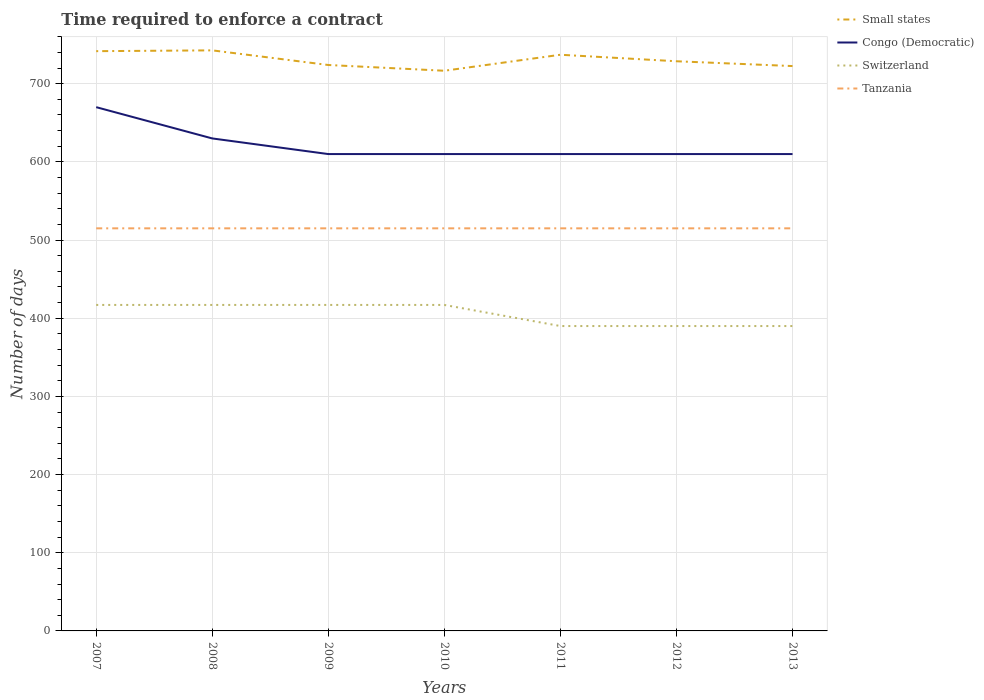Does the line corresponding to Tanzania intersect with the line corresponding to Switzerland?
Your answer should be very brief. No. Is the number of lines equal to the number of legend labels?
Keep it short and to the point. Yes. Across all years, what is the maximum number of days required to enforce a contract in Tanzania?
Ensure brevity in your answer.  515. In which year was the number of days required to enforce a contract in Congo (Democratic) maximum?
Offer a very short reply. 2009. What is the total number of days required to enforce a contract in Congo (Democratic) in the graph?
Your response must be concise. 60. What is the difference between the highest and the second highest number of days required to enforce a contract in Small states?
Give a very brief answer. 26.08. What is the difference between the highest and the lowest number of days required to enforce a contract in Congo (Democratic)?
Your response must be concise. 2. How many years are there in the graph?
Your answer should be compact. 7. What is the difference between two consecutive major ticks on the Y-axis?
Offer a very short reply. 100. How many legend labels are there?
Ensure brevity in your answer.  4. What is the title of the graph?
Offer a terse response. Time required to enforce a contract. Does "Finland" appear as one of the legend labels in the graph?
Provide a short and direct response. No. What is the label or title of the Y-axis?
Keep it short and to the point. Number of days. What is the Number of days of Small states in 2007?
Keep it short and to the point. 741.64. What is the Number of days in Congo (Democratic) in 2007?
Offer a very short reply. 670. What is the Number of days in Switzerland in 2007?
Keep it short and to the point. 417. What is the Number of days in Tanzania in 2007?
Ensure brevity in your answer.  515. What is the Number of days of Small states in 2008?
Your answer should be compact. 742.67. What is the Number of days in Congo (Democratic) in 2008?
Ensure brevity in your answer.  630. What is the Number of days of Switzerland in 2008?
Make the answer very short. 417. What is the Number of days of Tanzania in 2008?
Offer a very short reply. 515. What is the Number of days in Small states in 2009?
Provide a succinct answer. 723.95. What is the Number of days of Congo (Democratic) in 2009?
Provide a short and direct response. 610. What is the Number of days of Switzerland in 2009?
Ensure brevity in your answer.  417. What is the Number of days in Tanzania in 2009?
Your response must be concise. 515. What is the Number of days of Small states in 2010?
Offer a very short reply. 716.59. What is the Number of days of Congo (Democratic) in 2010?
Make the answer very short. 610. What is the Number of days of Switzerland in 2010?
Provide a short and direct response. 417. What is the Number of days in Tanzania in 2010?
Make the answer very short. 515. What is the Number of days in Small states in 2011?
Your answer should be very brief. 737.05. What is the Number of days in Congo (Democratic) in 2011?
Offer a very short reply. 610. What is the Number of days in Switzerland in 2011?
Provide a short and direct response. 390. What is the Number of days of Tanzania in 2011?
Keep it short and to the point. 515. What is the Number of days in Small states in 2012?
Give a very brief answer. 728.73. What is the Number of days of Congo (Democratic) in 2012?
Give a very brief answer. 610. What is the Number of days in Switzerland in 2012?
Your response must be concise. 390. What is the Number of days of Tanzania in 2012?
Your response must be concise. 515. What is the Number of days in Small states in 2013?
Make the answer very short. 722.58. What is the Number of days of Congo (Democratic) in 2013?
Provide a short and direct response. 610. What is the Number of days in Switzerland in 2013?
Offer a very short reply. 390. What is the Number of days of Tanzania in 2013?
Ensure brevity in your answer.  515. Across all years, what is the maximum Number of days in Small states?
Give a very brief answer. 742.67. Across all years, what is the maximum Number of days of Congo (Democratic)?
Offer a terse response. 670. Across all years, what is the maximum Number of days of Switzerland?
Give a very brief answer. 417. Across all years, what is the maximum Number of days in Tanzania?
Make the answer very short. 515. Across all years, what is the minimum Number of days in Small states?
Offer a terse response. 716.59. Across all years, what is the minimum Number of days of Congo (Democratic)?
Provide a succinct answer. 610. Across all years, what is the minimum Number of days of Switzerland?
Your answer should be very brief. 390. Across all years, what is the minimum Number of days of Tanzania?
Offer a terse response. 515. What is the total Number of days of Small states in the graph?
Provide a succinct answer. 5113.2. What is the total Number of days in Congo (Democratic) in the graph?
Give a very brief answer. 4350. What is the total Number of days of Switzerland in the graph?
Your response must be concise. 2838. What is the total Number of days in Tanzania in the graph?
Give a very brief answer. 3605. What is the difference between the Number of days in Small states in 2007 and that in 2008?
Provide a succinct answer. -1.03. What is the difference between the Number of days of Switzerland in 2007 and that in 2008?
Your response must be concise. 0. What is the difference between the Number of days in Small states in 2007 and that in 2009?
Your answer should be compact. 17.69. What is the difference between the Number of days of Congo (Democratic) in 2007 and that in 2009?
Your answer should be compact. 60. What is the difference between the Number of days of Switzerland in 2007 and that in 2009?
Your answer should be very brief. 0. What is the difference between the Number of days of Small states in 2007 and that in 2010?
Keep it short and to the point. 25.05. What is the difference between the Number of days of Congo (Democratic) in 2007 and that in 2010?
Offer a very short reply. 60. What is the difference between the Number of days in Small states in 2007 and that in 2011?
Provide a succinct answer. 4.59. What is the difference between the Number of days of Congo (Democratic) in 2007 and that in 2011?
Give a very brief answer. 60. What is the difference between the Number of days of Tanzania in 2007 and that in 2011?
Your answer should be very brief. 0. What is the difference between the Number of days of Small states in 2007 and that in 2012?
Your answer should be very brief. 12.92. What is the difference between the Number of days of Switzerland in 2007 and that in 2012?
Your answer should be very brief. 27. What is the difference between the Number of days in Small states in 2007 and that in 2013?
Keep it short and to the point. 19.07. What is the difference between the Number of days of Congo (Democratic) in 2007 and that in 2013?
Your answer should be compact. 60. What is the difference between the Number of days in Small states in 2008 and that in 2009?
Give a very brief answer. 18.72. What is the difference between the Number of days of Tanzania in 2008 and that in 2009?
Offer a very short reply. 0. What is the difference between the Number of days of Small states in 2008 and that in 2010?
Your answer should be compact. 26.08. What is the difference between the Number of days of Tanzania in 2008 and that in 2010?
Your response must be concise. 0. What is the difference between the Number of days in Small states in 2008 and that in 2011?
Provide a succinct answer. 5.62. What is the difference between the Number of days in Tanzania in 2008 and that in 2011?
Your answer should be very brief. 0. What is the difference between the Number of days of Small states in 2008 and that in 2012?
Provide a succinct answer. 13.94. What is the difference between the Number of days in Congo (Democratic) in 2008 and that in 2012?
Offer a terse response. 20. What is the difference between the Number of days of Small states in 2008 and that in 2013?
Ensure brevity in your answer.  20.09. What is the difference between the Number of days of Congo (Democratic) in 2008 and that in 2013?
Offer a terse response. 20. What is the difference between the Number of days in Switzerland in 2008 and that in 2013?
Ensure brevity in your answer.  27. What is the difference between the Number of days in Tanzania in 2008 and that in 2013?
Offer a very short reply. 0. What is the difference between the Number of days in Small states in 2009 and that in 2010?
Keep it short and to the point. 7.36. What is the difference between the Number of days in Congo (Democratic) in 2009 and that in 2010?
Offer a very short reply. 0. What is the difference between the Number of days in Switzerland in 2009 and that in 2010?
Give a very brief answer. 0. What is the difference between the Number of days in Tanzania in 2009 and that in 2010?
Provide a short and direct response. 0. What is the difference between the Number of days of Small states in 2009 and that in 2011?
Offer a terse response. -13.1. What is the difference between the Number of days of Small states in 2009 and that in 2012?
Provide a succinct answer. -4.78. What is the difference between the Number of days in Congo (Democratic) in 2009 and that in 2012?
Ensure brevity in your answer.  0. What is the difference between the Number of days in Switzerland in 2009 and that in 2012?
Make the answer very short. 27. What is the difference between the Number of days in Small states in 2009 and that in 2013?
Give a very brief answer. 1.37. What is the difference between the Number of days of Congo (Democratic) in 2009 and that in 2013?
Give a very brief answer. 0. What is the difference between the Number of days of Small states in 2010 and that in 2011?
Provide a short and direct response. -20.46. What is the difference between the Number of days of Switzerland in 2010 and that in 2011?
Offer a very short reply. 27. What is the difference between the Number of days of Tanzania in 2010 and that in 2011?
Your response must be concise. 0. What is the difference between the Number of days in Small states in 2010 and that in 2012?
Provide a succinct answer. -12.14. What is the difference between the Number of days of Congo (Democratic) in 2010 and that in 2012?
Your answer should be very brief. 0. What is the difference between the Number of days in Switzerland in 2010 and that in 2012?
Offer a terse response. 27. What is the difference between the Number of days of Tanzania in 2010 and that in 2012?
Offer a terse response. 0. What is the difference between the Number of days in Small states in 2010 and that in 2013?
Ensure brevity in your answer.  -5.99. What is the difference between the Number of days of Congo (Democratic) in 2010 and that in 2013?
Your answer should be very brief. 0. What is the difference between the Number of days of Switzerland in 2010 and that in 2013?
Make the answer very short. 27. What is the difference between the Number of days of Tanzania in 2010 and that in 2013?
Make the answer very short. 0. What is the difference between the Number of days of Small states in 2011 and that in 2012?
Provide a short and direct response. 8.32. What is the difference between the Number of days in Tanzania in 2011 and that in 2012?
Your answer should be compact. 0. What is the difference between the Number of days of Small states in 2011 and that in 2013?
Make the answer very short. 14.47. What is the difference between the Number of days in Tanzania in 2011 and that in 2013?
Give a very brief answer. 0. What is the difference between the Number of days in Small states in 2012 and that in 2013?
Provide a succinct answer. 6.15. What is the difference between the Number of days in Congo (Democratic) in 2012 and that in 2013?
Your response must be concise. 0. What is the difference between the Number of days of Switzerland in 2012 and that in 2013?
Your answer should be compact. 0. What is the difference between the Number of days in Tanzania in 2012 and that in 2013?
Your response must be concise. 0. What is the difference between the Number of days of Small states in 2007 and the Number of days of Congo (Democratic) in 2008?
Keep it short and to the point. 111.64. What is the difference between the Number of days in Small states in 2007 and the Number of days in Switzerland in 2008?
Provide a succinct answer. 324.64. What is the difference between the Number of days of Small states in 2007 and the Number of days of Tanzania in 2008?
Ensure brevity in your answer.  226.64. What is the difference between the Number of days in Congo (Democratic) in 2007 and the Number of days in Switzerland in 2008?
Offer a terse response. 253. What is the difference between the Number of days in Congo (Democratic) in 2007 and the Number of days in Tanzania in 2008?
Your response must be concise. 155. What is the difference between the Number of days in Switzerland in 2007 and the Number of days in Tanzania in 2008?
Offer a terse response. -98. What is the difference between the Number of days of Small states in 2007 and the Number of days of Congo (Democratic) in 2009?
Your answer should be very brief. 131.64. What is the difference between the Number of days in Small states in 2007 and the Number of days in Switzerland in 2009?
Provide a short and direct response. 324.64. What is the difference between the Number of days of Small states in 2007 and the Number of days of Tanzania in 2009?
Ensure brevity in your answer.  226.64. What is the difference between the Number of days of Congo (Democratic) in 2007 and the Number of days of Switzerland in 2009?
Give a very brief answer. 253. What is the difference between the Number of days in Congo (Democratic) in 2007 and the Number of days in Tanzania in 2009?
Offer a very short reply. 155. What is the difference between the Number of days of Switzerland in 2007 and the Number of days of Tanzania in 2009?
Your answer should be compact. -98. What is the difference between the Number of days in Small states in 2007 and the Number of days in Congo (Democratic) in 2010?
Offer a terse response. 131.64. What is the difference between the Number of days of Small states in 2007 and the Number of days of Switzerland in 2010?
Make the answer very short. 324.64. What is the difference between the Number of days of Small states in 2007 and the Number of days of Tanzania in 2010?
Provide a short and direct response. 226.64. What is the difference between the Number of days of Congo (Democratic) in 2007 and the Number of days of Switzerland in 2010?
Your answer should be very brief. 253. What is the difference between the Number of days in Congo (Democratic) in 2007 and the Number of days in Tanzania in 2010?
Provide a short and direct response. 155. What is the difference between the Number of days in Switzerland in 2007 and the Number of days in Tanzania in 2010?
Offer a very short reply. -98. What is the difference between the Number of days of Small states in 2007 and the Number of days of Congo (Democratic) in 2011?
Give a very brief answer. 131.64. What is the difference between the Number of days in Small states in 2007 and the Number of days in Switzerland in 2011?
Offer a very short reply. 351.64. What is the difference between the Number of days in Small states in 2007 and the Number of days in Tanzania in 2011?
Make the answer very short. 226.64. What is the difference between the Number of days of Congo (Democratic) in 2007 and the Number of days of Switzerland in 2011?
Provide a short and direct response. 280. What is the difference between the Number of days of Congo (Democratic) in 2007 and the Number of days of Tanzania in 2011?
Make the answer very short. 155. What is the difference between the Number of days of Switzerland in 2007 and the Number of days of Tanzania in 2011?
Make the answer very short. -98. What is the difference between the Number of days in Small states in 2007 and the Number of days in Congo (Democratic) in 2012?
Give a very brief answer. 131.64. What is the difference between the Number of days in Small states in 2007 and the Number of days in Switzerland in 2012?
Provide a succinct answer. 351.64. What is the difference between the Number of days in Small states in 2007 and the Number of days in Tanzania in 2012?
Provide a succinct answer. 226.64. What is the difference between the Number of days of Congo (Democratic) in 2007 and the Number of days of Switzerland in 2012?
Make the answer very short. 280. What is the difference between the Number of days in Congo (Democratic) in 2007 and the Number of days in Tanzania in 2012?
Make the answer very short. 155. What is the difference between the Number of days in Switzerland in 2007 and the Number of days in Tanzania in 2012?
Provide a succinct answer. -98. What is the difference between the Number of days of Small states in 2007 and the Number of days of Congo (Democratic) in 2013?
Your answer should be very brief. 131.64. What is the difference between the Number of days in Small states in 2007 and the Number of days in Switzerland in 2013?
Your answer should be compact. 351.64. What is the difference between the Number of days of Small states in 2007 and the Number of days of Tanzania in 2013?
Give a very brief answer. 226.64. What is the difference between the Number of days in Congo (Democratic) in 2007 and the Number of days in Switzerland in 2013?
Your answer should be very brief. 280. What is the difference between the Number of days in Congo (Democratic) in 2007 and the Number of days in Tanzania in 2013?
Offer a terse response. 155. What is the difference between the Number of days of Switzerland in 2007 and the Number of days of Tanzania in 2013?
Make the answer very short. -98. What is the difference between the Number of days of Small states in 2008 and the Number of days of Congo (Democratic) in 2009?
Make the answer very short. 132.67. What is the difference between the Number of days in Small states in 2008 and the Number of days in Switzerland in 2009?
Provide a short and direct response. 325.67. What is the difference between the Number of days in Small states in 2008 and the Number of days in Tanzania in 2009?
Offer a very short reply. 227.67. What is the difference between the Number of days of Congo (Democratic) in 2008 and the Number of days of Switzerland in 2009?
Provide a short and direct response. 213. What is the difference between the Number of days in Congo (Democratic) in 2008 and the Number of days in Tanzania in 2009?
Make the answer very short. 115. What is the difference between the Number of days of Switzerland in 2008 and the Number of days of Tanzania in 2009?
Offer a very short reply. -98. What is the difference between the Number of days in Small states in 2008 and the Number of days in Congo (Democratic) in 2010?
Offer a very short reply. 132.67. What is the difference between the Number of days in Small states in 2008 and the Number of days in Switzerland in 2010?
Your response must be concise. 325.67. What is the difference between the Number of days in Small states in 2008 and the Number of days in Tanzania in 2010?
Provide a succinct answer. 227.67. What is the difference between the Number of days in Congo (Democratic) in 2008 and the Number of days in Switzerland in 2010?
Offer a terse response. 213. What is the difference between the Number of days of Congo (Democratic) in 2008 and the Number of days of Tanzania in 2010?
Provide a short and direct response. 115. What is the difference between the Number of days of Switzerland in 2008 and the Number of days of Tanzania in 2010?
Make the answer very short. -98. What is the difference between the Number of days of Small states in 2008 and the Number of days of Congo (Democratic) in 2011?
Make the answer very short. 132.67. What is the difference between the Number of days of Small states in 2008 and the Number of days of Switzerland in 2011?
Provide a succinct answer. 352.67. What is the difference between the Number of days in Small states in 2008 and the Number of days in Tanzania in 2011?
Your answer should be compact. 227.67. What is the difference between the Number of days in Congo (Democratic) in 2008 and the Number of days in Switzerland in 2011?
Offer a terse response. 240. What is the difference between the Number of days in Congo (Democratic) in 2008 and the Number of days in Tanzania in 2011?
Your response must be concise. 115. What is the difference between the Number of days in Switzerland in 2008 and the Number of days in Tanzania in 2011?
Provide a short and direct response. -98. What is the difference between the Number of days of Small states in 2008 and the Number of days of Congo (Democratic) in 2012?
Your response must be concise. 132.67. What is the difference between the Number of days in Small states in 2008 and the Number of days in Switzerland in 2012?
Provide a short and direct response. 352.67. What is the difference between the Number of days of Small states in 2008 and the Number of days of Tanzania in 2012?
Offer a terse response. 227.67. What is the difference between the Number of days in Congo (Democratic) in 2008 and the Number of days in Switzerland in 2012?
Provide a succinct answer. 240. What is the difference between the Number of days of Congo (Democratic) in 2008 and the Number of days of Tanzania in 2012?
Give a very brief answer. 115. What is the difference between the Number of days in Switzerland in 2008 and the Number of days in Tanzania in 2012?
Give a very brief answer. -98. What is the difference between the Number of days of Small states in 2008 and the Number of days of Congo (Democratic) in 2013?
Offer a very short reply. 132.67. What is the difference between the Number of days of Small states in 2008 and the Number of days of Switzerland in 2013?
Ensure brevity in your answer.  352.67. What is the difference between the Number of days in Small states in 2008 and the Number of days in Tanzania in 2013?
Give a very brief answer. 227.67. What is the difference between the Number of days of Congo (Democratic) in 2008 and the Number of days of Switzerland in 2013?
Offer a terse response. 240. What is the difference between the Number of days in Congo (Democratic) in 2008 and the Number of days in Tanzania in 2013?
Your answer should be compact. 115. What is the difference between the Number of days in Switzerland in 2008 and the Number of days in Tanzania in 2013?
Provide a short and direct response. -98. What is the difference between the Number of days in Small states in 2009 and the Number of days in Congo (Democratic) in 2010?
Offer a very short reply. 113.95. What is the difference between the Number of days of Small states in 2009 and the Number of days of Switzerland in 2010?
Offer a very short reply. 306.95. What is the difference between the Number of days of Small states in 2009 and the Number of days of Tanzania in 2010?
Your response must be concise. 208.95. What is the difference between the Number of days of Congo (Democratic) in 2009 and the Number of days of Switzerland in 2010?
Make the answer very short. 193. What is the difference between the Number of days in Congo (Democratic) in 2009 and the Number of days in Tanzania in 2010?
Ensure brevity in your answer.  95. What is the difference between the Number of days in Switzerland in 2009 and the Number of days in Tanzania in 2010?
Make the answer very short. -98. What is the difference between the Number of days in Small states in 2009 and the Number of days in Congo (Democratic) in 2011?
Your answer should be compact. 113.95. What is the difference between the Number of days of Small states in 2009 and the Number of days of Switzerland in 2011?
Make the answer very short. 333.95. What is the difference between the Number of days in Small states in 2009 and the Number of days in Tanzania in 2011?
Provide a short and direct response. 208.95. What is the difference between the Number of days in Congo (Democratic) in 2009 and the Number of days in Switzerland in 2011?
Your answer should be very brief. 220. What is the difference between the Number of days in Congo (Democratic) in 2009 and the Number of days in Tanzania in 2011?
Your answer should be very brief. 95. What is the difference between the Number of days in Switzerland in 2009 and the Number of days in Tanzania in 2011?
Offer a very short reply. -98. What is the difference between the Number of days in Small states in 2009 and the Number of days in Congo (Democratic) in 2012?
Your response must be concise. 113.95. What is the difference between the Number of days in Small states in 2009 and the Number of days in Switzerland in 2012?
Give a very brief answer. 333.95. What is the difference between the Number of days in Small states in 2009 and the Number of days in Tanzania in 2012?
Ensure brevity in your answer.  208.95. What is the difference between the Number of days of Congo (Democratic) in 2009 and the Number of days of Switzerland in 2012?
Offer a very short reply. 220. What is the difference between the Number of days of Switzerland in 2009 and the Number of days of Tanzania in 2012?
Provide a succinct answer. -98. What is the difference between the Number of days of Small states in 2009 and the Number of days of Congo (Democratic) in 2013?
Provide a short and direct response. 113.95. What is the difference between the Number of days of Small states in 2009 and the Number of days of Switzerland in 2013?
Provide a succinct answer. 333.95. What is the difference between the Number of days in Small states in 2009 and the Number of days in Tanzania in 2013?
Make the answer very short. 208.95. What is the difference between the Number of days in Congo (Democratic) in 2009 and the Number of days in Switzerland in 2013?
Give a very brief answer. 220. What is the difference between the Number of days in Congo (Democratic) in 2009 and the Number of days in Tanzania in 2013?
Offer a terse response. 95. What is the difference between the Number of days of Switzerland in 2009 and the Number of days of Tanzania in 2013?
Ensure brevity in your answer.  -98. What is the difference between the Number of days in Small states in 2010 and the Number of days in Congo (Democratic) in 2011?
Provide a short and direct response. 106.59. What is the difference between the Number of days of Small states in 2010 and the Number of days of Switzerland in 2011?
Give a very brief answer. 326.59. What is the difference between the Number of days of Small states in 2010 and the Number of days of Tanzania in 2011?
Offer a terse response. 201.59. What is the difference between the Number of days of Congo (Democratic) in 2010 and the Number of days of Switzerland in 2011?
Give a very brief answer. 220. What is the difference between the Number of days in Congo (Democratic) in 2010 and the Number of days in Tanzania in 2011?
Your response must be concise. 95. What is the difference between the Number of days in Switzerland in 2010 and the Number of days in Tanzania in 2011?
Offer a very short reply. -98. What is the difference between the Number of days of Small states in 2010 and the Number of days of Congo (Democratic) in 2012?
Provide a short and direct response. 106.59. What is the difference between the Number of days in Small states in 2010 and the Number of days in Switzerland in 2012?
Offer a terse response. 326.59. What is the difference between the Number of days of Small states in 2010 and the Number of days of Tanzania in 2012?
Your response must be concise. 201.59. What is the difference between the Number of days of Congo (Democratic) in 2010 and the Number of days of Switzerland in 2012?
Your answer should be compact. 220. What is the difference between the Number of days in Switzerland in 2010 and the Number of days in Tanzania in 2012?
Ensure brevity in your answer.  -98. What is the difference between the Number of days of Small states in 2010 and the Number of days of Congo (Democratic) in 2013?
Keep it short and to the point. 106.59. What is the difference between the Number of days of Small states in 2010 and the Number of days of Switzerland in 2013?
Provide a succinct answer. 326.59. What is the difference between the Number of days in Small states in 2010 and the Number of days in Tanzania in 2013?
Provide a succinct answer. 201.59. What is the difference between the Number of days of Congo (Democratic) in 2010 and the Number of days of Switzerland in 2013?
Your response must be concise. 220. What is the difference between the Number of days of Congo (Democratic) in 2010 and the Number of days of Tanzania in 2013?
Your response must be concise. 95. What is the difference between the Number of days of Switzerland in 2010 and the Number of days of Tanzania in 2013?
Your response must be concise. -98. What is the difference between the Number of days of Small states in 2011 and the Number of days of Congo (Democratic) in 2012?
Your answer should be compact. 127.05. What is the difference between the Number of days in Small states in 2011 and the Number of days in Switzerland in 2012?
Your answer should be compact. 347.05. What is the difference between the Number of days in Small states in 2011 and the Number of days in Tanzania in 2012?
Your answer should be compact. 222.05. What is the difference between the Number of days in Congo (Democratic) in 2011 and the Number of days in Switzerland in 2012?
Offer a very short reply. 220. What is the difference between the Number of days of Congo (Democratic) in 2011 and the Number of days of Tanzania in 2012?
Your answer should be very brief. 95. What is the difference between the Number of days of Switzerland in 2011 and the Number of days of Tanzania in 2012?
Give a very brief answer. -125. What is the difference between the Number of days in Small states in 2011 and the Number of days in Congo (Democratic) in 2013?
Ensure brevity in your answer.  127.05. What is the difference between the Number of days in Small states in 2011 and the Number of days in Switzerland in 2013?
Your answer should be very brief. 347.05. What is the difference between the Number of days of Small states in 2011 and the Number of days of Tanzania in 2013?
Give a very brief answer. 222.05. What is the difference between the Number of days in Congo (Democratic) in 2011 and the Number of days in Switzerland in 2013?
Your response must be concise. 220. What is the difference between the Number of days in Congo (Democratic) in 2011 and the Number of days in Tanzania in 2013?
Ensure brevity in your answer.  95. What is the difference between the Number of days of Switzerland in 2011 and the Number of days of Tanzania in 2013?
Ensure brevity in your answer.  -125. What is the difference between the Number of days of Small states in 2012 and the Number of days of Congo (Democratic) in 2013?
Your answer should be very brief. 118.72. What is the difference between the Number of days of Small states in 2012 and the Number of days of Switzerland in 2013?
Offer a very short reply. 338.73. What is the difference between the Number of days in Small states in 2012 and the Number of days in Tanzania in 2013?
Keep it short and to the point. 213.72. What is the difference between the Number of days in Congo (Democratic) in 2012 and the Number of days in Switzerland in 2013?
Your answer should be compact. 220. What is the difference between the Number of days in Congo (Democratic) in 2012 and the Number of days in Tanzania in 2013?
Your response must be concise. 95. What is the difference between the Number of days of Switzerland in 2012 and the Number of days of Tanzania in 2013?
Keep it short and to the point. -125. What is the average Number of days of Small states per year?
Offer a terse response. 730.46. What is the average Number of days in Congo (Democratic) per year?
Offer a very short reply. 621.43. What is the average Number of days of Switzerland per year?
Ensure brevity in your answer.  405.43. What is the average Number of days of Tanzania per year?
Make the answer very short. 515. In the year 2007, what is the difference between the Number of days in Small states and Number of days in Congo (Democratic)?
Provide a succinct answer. 71.64. In the year 2007, what is the difference between the Number of days in Small states and Number of days in Switzerland?
Ensure brevity in your answer.  324.64. In the year 2007, what is the difference between the Number of days of Small states and Number of days of Tanzania?
Ensure brevity in your answer.  226.64. In the year 2007, what is the difference between the Number of days in Congo (Democratic) and Number of days in Switzerland?
Offer a very short reply. 253. In the year 2007, what is the difference between the Number of days in Congo (Democratic) and Number of days in Tanzania?
Provide a short and direct response. 155. In the year 2007, what is the difference between the Number of days in Switzerland and Number of days in Tanzania?
Ensure brevity in your answer.  -98. In the year 2008, what is the difference between the Number of days in Small states and Number of days in Congo (Democratic)?
Your answer should be compact. 112.67. In the year 2008, what is the difference between the Number of days in Small states and Number of days in Switzerland?
Keep it short and to the point. 325.67. In the year 2008, what is the difference between the Number of days of Small states and Number of days of Tanzania?
Provide a succinct answer. 227.67. In the year 2008, what is the difference between the Number of days in Congo (Democratic) and Number of days in Switzerland?
Offer a very short reply. 213. In the year 2008, what is the difference between the Number of days of Congo (Democratic) and Number of days of Tanzania?
Keep it short and to the point. 115. In the year 2008, what is the difference between the Number of days in Switzerland and Number of days in Tanzania?
Ensure brevity in your answer.  -98. In the year 2009, what is the difference between the Number of days in Small states and Number of days in Congo (Democratic)?
Your response must be concise. 113.95. In the year 2009, what is the difference between the Number of days in Small states and Number of days in Switzerland?
Provide a succinct answer. 306.95. In the year 2009, what is the difference between the Number of days in Small states and Number of days in Tanzania?
Your response must be concise. 208.95. In the year 2009, what is the difference between the Number of days of Congo (Democratic) and Number of days of Switzerland?
Your response must be concise. 193. In the year 2009, what is the difference between the Number of days of Congo (Democratic) and Number of days of Tanzania?
Make the answer very short. 95. In the year 2009, what is the difference between the Number of days in Switzerland and Number of days in Tanzania?
Offer a terse response. -98. In the year 2010, what is the difference between the Number of days of Small states and Number of days of Congo (Democratic)?
Your answer should be very brief. 106.59. In the year 2010, what is the difference between the Number of days of Small states and Number of days of Switzerland?
Provide a short and direct response. 299.59. In the year 2010, what is the difference between the Number of days of Small states and Number of days of Tanzania?
Offer a very short reply. 201.59. In the year 2010, what is the difference between the Number of days of Congo (Democratic) and Number of days of Switzerland?
Your answer should be very brief. 193. In the year 2010, what is the difference between the Number of days in Congo (Democratic) and Number of days in Tanzania?
Make the answer very short. 95. In the year 2010, what is the difference between the Number of days of Switzerland and Number of days of Tanzania?
Offer a very short reply. -98. In the year 2011, what is the difference between the Number of days in Small states and Number of days in Congo (Democratic)?
Offer a terse response. 127.05. In the year 2011, what is the difference between the Number of days of Small states and Number of days of Switzerland?
Offer a very short reply. 347.05. In the year 2011, what is the difference between the Number of days in Small states and Number of days in Tanzania?
Provide a succinct answer. 222.05. In the year 2011, what is the difference between the Number of days of Congo (Democratic) and Number of days of Switzerland?
Give a very brief answer. 220. In the year 2011, what is the difference between the Number of days of Switzerland and Number of days of Tanzania?
Keep it short and to the point. -125. In the year 2012, what is the difference between the Number of days in Small states and Number of days in Congo (Democratic)?
Ensure brevity in your answer.  118.72. In the year 2012, what is the difference between the Number of days of Small states and Number of days of Switzerland?
Your response must be concise. 338.73. In the year 2012, what is the difference between the Number of days in Small states and Number of days in Tanzania?
Provide a succinct answer. 213.72. In the year 2012, what is the difference between the Number of days of Congo (Democratic) and Number of days of Switzerland?
Your response must be concise. 220. In the year 2012, what is the difference between the Number of days of Congo (Democratic) and Number of days of Tanzania?
Offer a very short reply. 95. In the year 2012, what is the difference between the Number of days of Switzerland and Number of days of Tanzania?
Your answer should be very brief. -125. In the year 2013, what is the difference between the Number of days in Small states and Number of days in Congo (Democratic)?
Your answer should be compact. 112.58. In the year 2013, what is the difference between the Number of days of Small states and Number of days of Switzerland?
Make the answer very short. 332.57. In the year 2013, what is the difference between the Number of days of Small states and Number of days of Tanzania?
Provide a short and direct response. 207.57. In the year 2013, what is the difference between the Number of days in Congo (Democratic) and Number of days in Switzerland?
Your response must be concise. 220. In the year 2013, what is the difference between the Number of days in Switzerland and Number of days in Tanzania?
Your response must be concise. -125. What is the ratio of the Number of days of Small states in 2007 to that in 2008?
Keep it short and to the point. 1. What is the ratio of the Number of days of Congo (Democratic) in 2007 to that in 2008?
Ensure brevity in your answer.  1.06. What is the ratio of the Number of days of Tanzania in 2007 to that in 2008?
Your answer should be very brief. 1. What is the ratio of the Number of days in Small states in 2007 to that in 2009?
Your answer should be compact. 1.02. What is the ratio of the Number of days of Congo (Democratic) in 2007 to that in 2009?
Provide a succinct answer. 1.1. What is the ratio of the Number of days in Small states in 2007 to that in 2010?
Provide a succinct answer. 1.03. What is the ratio of the Number of days in Congo (Democratic) in 2007 to that in 2010?
Offer a very short reply. 1.1. What is the ratio of the Number of days in Switzerland in 2007 to that in 2010?
Keep it short and to the point. 1. What is the ratio of the Number of days of Congo (Democratic) in 2007 to that in 2011?
Offer a very short reply. 1.1. What is the ratio of the Number of days of Switzerland in 2007 to that in 2011?
Keep it short and to the point. 1.07. What is the ratio of the Number of days in Tanzania in 2007 to that in 2011?
Your answer should be very brief. 1. What is the ratio of the Number of days of Small states in 2007 to that in 2012?
Your answer should be very brief. 1.02. What is the ratio of the Number of days of Congo (Democratic) in 2007 to that in 2012?
Keep it short and to the point. 1.1. What is the ratio of the Number of days of Switzerland in 2007 to that in 2012?
Provide a succinct answer. 1.07. What is the ratio of the Number of days in Tanzania in 2007 to that in 2012?
Make the answer very short. 1. What is the ratio of the Number of days in Small states in 2007 to that in 2013?
Make the answer very short. 1.03. What is the ratio of the Number of days of Congo (Democratic) in 2007 to that in 2013?
Offer a very short reply. 1.1. What is the ratio of the Number of days of Switzerland in 2007 to that in 2013?
Keep it short and to the point. 1.07. What is the ratio of the Number of days of Tanzania in 2007 to that in 2013?
Your answer should be compact. 1. What is the ratio of the Number of days in Small states in 2008 to that in 2009?
Offer a terse response. 1.03. What is the ratio of the Number of days in Congo (Democratic) in 2008 to that in 2009?
Offer a terse response. 1.03. What is the ratio of the Number of days of Small states in 2008 to that in 2010?
Provide a succinct answer. 1.04. What is the ratio of the Number of days of Congo (Democratic) in 2008 to that in 2010?
Ensure brevity in your answer.  1.03. What is the ratio of the Number of days of Switzerland in 2008 to that in 2010?
Keep it short and to the point. 1. What is the ratio of the Number of days of Tanzania in 2008 to that in 2010?
Ensure brevity in your answer.  1. What is the ratio of the Number of days in Small states in 2008 to that in 2011?
Offer a very short reply. 1.01. What is the ratio of the Number of days in Congo (Democratic) in 2008 to that in 2011?
Your answer should be very brief. 1.03. What is the ratio of the Number of days of Switzerland in 2008 to that in 2011?
Give a very brief answer. 1.07. What is the ratio of the Number of days in Tanzania in 2008 to that in 2011?
Keep it short and to the point. 1. What is the ratio of the Number of days in Small states in 2008 to that in 2012?
Your response must be concise. 1.02. What is the ratio of the Number of days of Congo (Democratic) in 2008 to that in 2012?
Give a very brief answer. 1.03. What is the ratio of the Number of days of Switzerland in 2008 to that in 2012?
Give a very brief answer. 1.07. What is the ratio of the Number of days in Small states in 2008 to that in 2013?
Offer a very short reply. 1.03. What is the ratio of the Number of days of Congo (Democratic) in 2008 to that in 2013?
Your response must be concise. 1.03. What is the ratio of the Number of days of Switzerland in 2008 to that in 2013?
Offer a terse response. 1.07. What is the ratio of the Number of days in Small states in 2009 to that in 2010?
Provide a short and direct response. 1.01. What is the ratio of the Number of days in Congo (Democratic) in 2009 to that in 2010?
Provide a succinct answer. 1. What is the ratio of the Number of days of Tanzania in 2009 to that in 2010?
Offer a terse response. 1. What is the ratio of the Number of days in Small states in 2009 to that in 2011?
Your response must be concise. 0.98. What is the ratio of the Number of days of Congo (Democratic) in 2009 to that in 2011?
Give a very brief answer. 1. What is the ratio of the Number of days of Switzerland in 2009 to that in 2011?
Offer a terse response. 1.07. What is the ratio of the Number of days of Tanzania in 2009 to that in 2011?
Provide a short and direct response. 1. What is the ratio of the Number of days in Small states in 2009 to that in 2012?
Your answer should be compact. 0.99. What is the ratio of the Number of days in Switzerland in 2009 to that in 2012?
Your answer should be compact. 1.07. What is the ratio of the Number of days in Switzerland in 2009 to that in 2013?
Provide a succinct answer. 1.07. What is the ratio of the Number of days in Tanzania in 2009 to that in 2013?
Keep it short and to the point. 1. What is the ratio of the Number of days of Small states in 2010 to that in 2011?
Provide a short and direct response. 0.97. What is the ratio of the Number of days in Switzerland in 2010 to that in 2011?
Your answer should be very brief. 1.07. What is the ratio of the Number of days in Tanzania in 2010 to that in 2011?
Give a very brief answer. 1. What is the ratio of the Number of days of Small states in 2010 to that in 2012?
Ensure brevity in your answer.  0.98. What is the ratio of the Number of days of Switzerland in 2010 to that in 2012?
Give a very brief answer. 1.07. What is the ratio of the Number of days of Small states in 2010 to that in 2013?
Provide a succinct answer. 0.99. What is the ratio of the Number of days of Switzerland in 2010 to that in 2013?
Give a very brief answer. 1.07. What is the ratio of the Number of days in Small states in 2011 to that in 2012?
Your answer should be compact. 1.01. What is the ratio of the Number of days in Congo (Democratic) in 2011 to that in 2012?
Your response must be concise. 1. What is the ratio of the Number of days in Tanzania in 2011 to that in 2012?
Make the answer very short. 1. What is the ratio of the Number of days in Congo (Democratic) in 2011 to that in 2013?
Provide a short and direct response. 1. What is the ratio of the Number of days of Switzerland in 2011 to that in 2013?
Offer a terse response. 1. What is the ratio of the Number of days in Small states in 2012 to that in 2013?
Ensure brevity in your answer.  1.01. What is the ratio of the Number of days of Congo (Democratic) in 2012 to that in 2013?
Make the answer very short. 1. What is the ratio of the Number of days in Switzerland in 2012 to that in 2013?
Give a very brief answer. 1. What is the difference between the highest and the second highest Number of days of Small states?
Ensure brevity in your answer.  1.03. What is the difference between the highest and the second highest Number of days of Congo (Democratic)?
Keep it short and to the point. 40. What is the difference between the highest and the second highest Number of days in Switzerland?
Keep it short and to the point. 0. What is the difference between the highest and the lowest Number of days of Small states?
Give a very brief answer. 26.08. What is the difference between the highest and the lowest Number of days of Congo (Democratic)?
Keep it short and to the point. 60. 